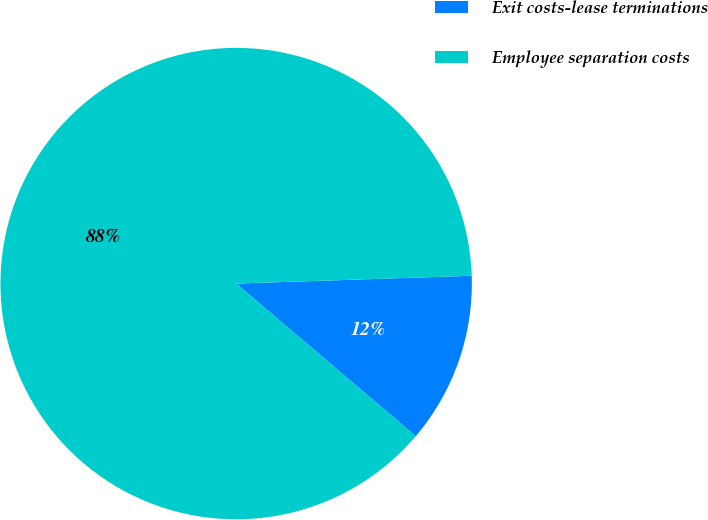Convert chart. <chart><loc_0><loc_0><loc_500><loc_500><pie_chart><fcel>Exit costs-lease terminations<fcel>Employee separation costs<nl><fcel>11.74%<fcel>88.26%<nl></chart> 